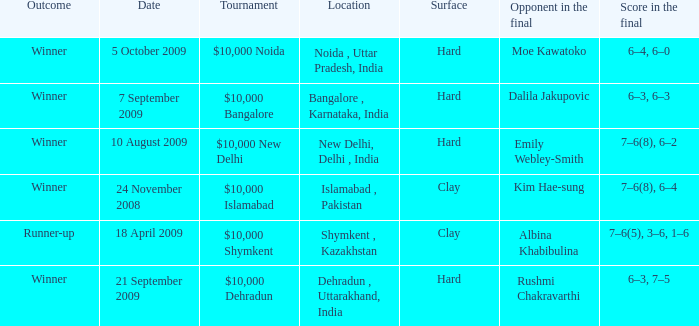What is the name of the tournament where outcome is runner-up $10,000 Shymkent. 